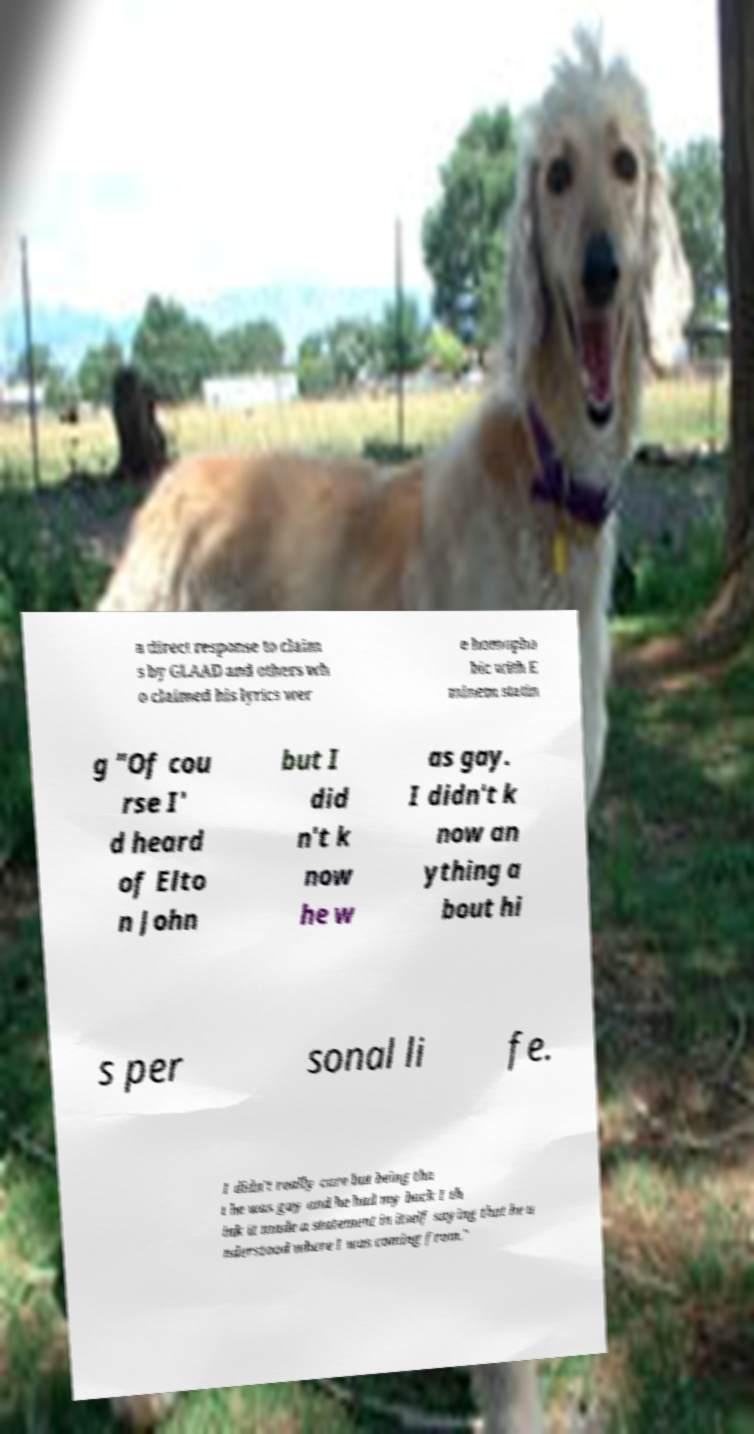Can you accurately transcribe the text from the provided image for me? a direct response to claim s by GLAAD and others wh o claimed his lyrics wer e homopho bic with E minem statin g "Of cou rse I' d heard of Elto n John but I did n't k now he w as gay. I didn't k now an ything a bout hi s per sonal li fe. I didn't really care but being tha t he was gay and he had my back I th ink it made a statement in itself saying that he u nderstood where I was coming from." 